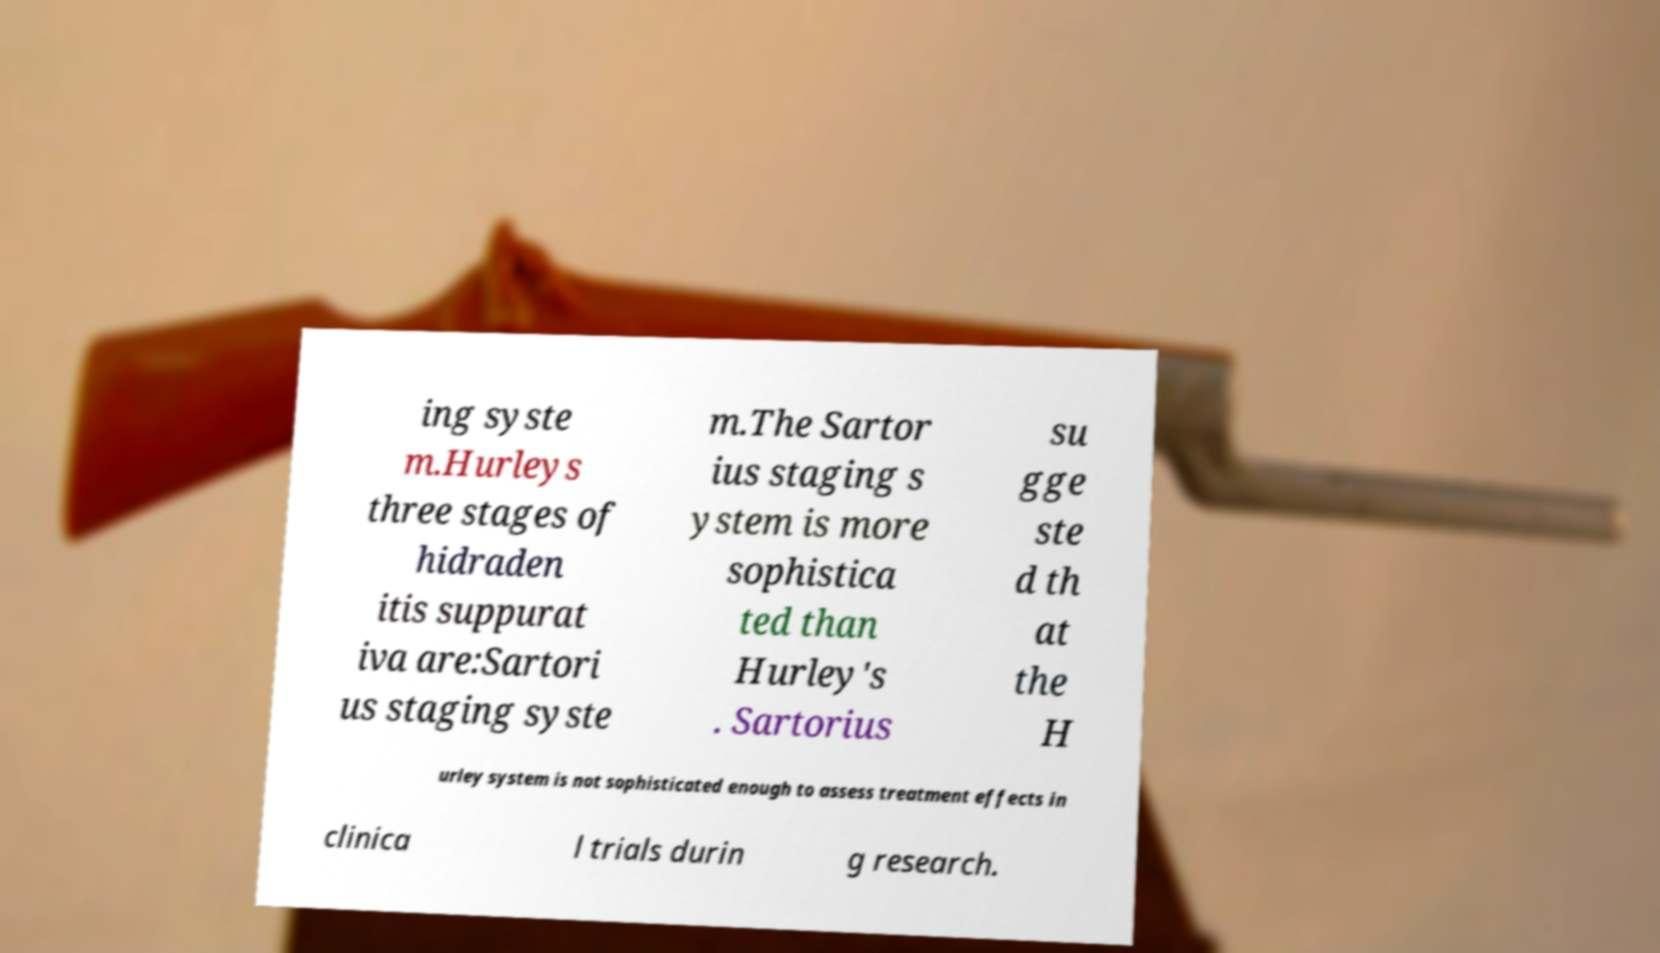For documentation purposes, I need the text within this image transcribed. Could you provide that? ing syste m.Hurleys three stages of hidraden itis suppurat iva are:Sartori us staging syste m.The Sartor ius staging s ystem is more sophistica ted than Hurley's . Sartorius su gge ste d th at the H urley system is not sophisticated enough to assess treatment effects in clinica l trials durin g research. 